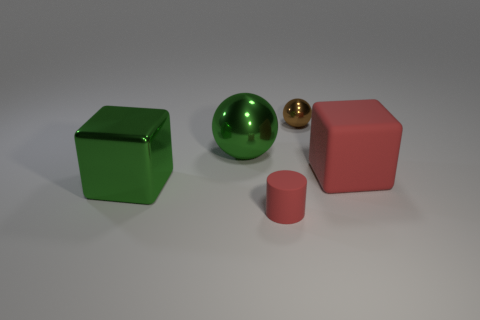Add 4 tiny cylinders. How many objects exist? 9 Subtract 1 cylinders. How many cylinders are left? 0 Subtract all green balls. How many balls are left? 1 Subtract all blocks. How many objects are left? 3 Subtract all yellow cubes. How many brown balls are left? 1 Subtract all large blocks. Subtract all matte cylinders. How many objects are left? 2 Add 2 metal objects. How many metal objects are left? 5 Add 3 gray rubber cylinders. How many gray rubber cylinders exist? 3 Subtract 0 blue cylinders. How many objects are left? 5 Subtract all brown spheres. Subtract all red cylinders. How many spheres are left? 1 